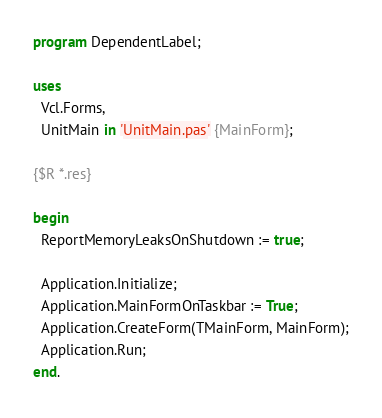<code> <loc_0><loc_0><loc_500><loc_500><_Pascal_>program DependentLabel;

uses
  Vcl.Forms,
  UnitMain in 'UnitMain.pas' {MainForm};

{$R *.res}

begin
  ReportMemoryLeaksOnShutdown := true;

  Application.Initialize;
  Application.MainFormOnTaskbar := True;
  Application.CreateForm(TMainForm, MainForm);
  Application.Run;
end.
</code> 